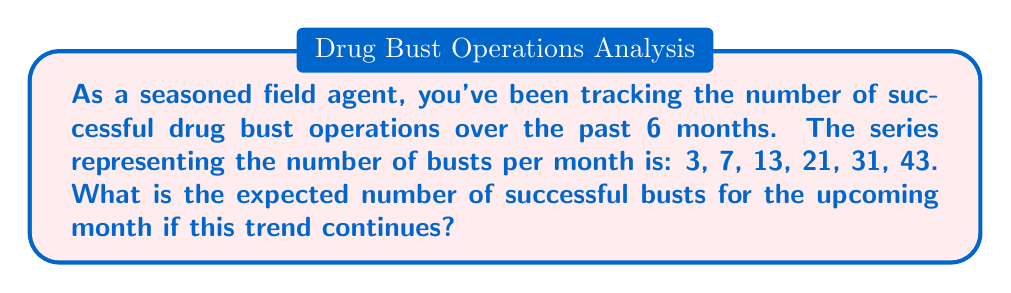Can you answer this question? To solve this problem, we need to identify the pattern in the given series:

1) First, let's calculate the differences between consecutive terms:
   $7 - 3 = 4$
   $13 - 7 = 6$
   $21 - 13 = 8$
   $31 - 21 = 10$
   $43 - 31 = 12$

2) We can see that the differences are increasing by 2 each time:
   $4, 6, 8, 10, 12$

3) This suggests that the series follows a quadratic pattern. The general form of a quadratic sequence is:

   $$a_n = an^2 + bn + c$$

   Where $n$ is the term number (starting from 0), and $a$, $b$, and $c$ are constants.

4) To find the next term, we need to determine the value for the 7th month (n = 6):

   $$a_6 = a(6^2) + b(6) + c = 36a + 6b + c$$

5) The difference between this term and the previous term would be:

   $$(36a + 6b + c) - (25a + 5b + c) = 11a + b = 14$$

   This is because the difference should be 2 more than the previous difference (12).

6) Solving this equation:

   $$11a + b = 14$$
   $$a = 1, b = 3, c = -1$$

7) Therefore, the general formula for this sequence is:

   $$a_n = n^2 + 3n - 1$$

8) For the 7th month (n = 7):

   $$a_7 = 7^2 + 3(7) - 1 = 49 + 21 - 1 = 69$$

Thus, the expected number of successful busts for the upcoming month is 69.
Answer: 69 